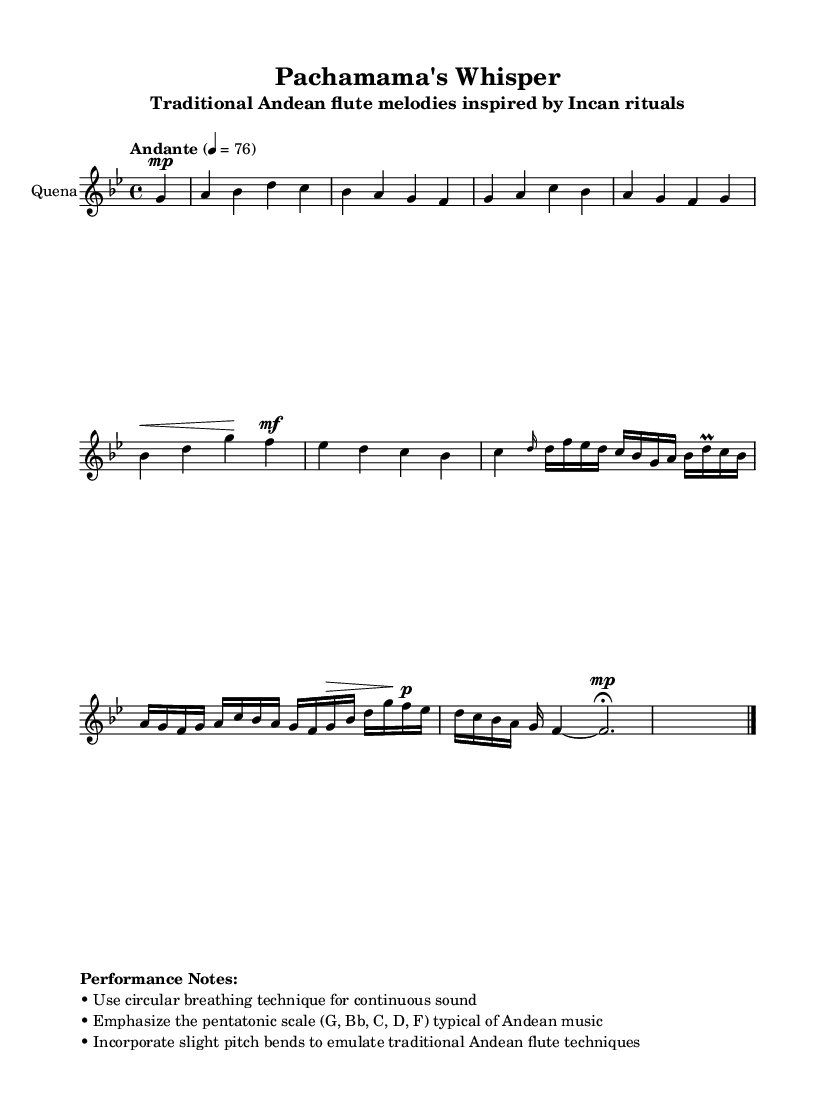What is the key signature of this music? The key signature indicates that the piece is in G minor, which includes two flats: B flat and E flat.
Answer: G minor What is the time signature of the piece? The time signature is found at the beginning of the score and is written as 4/4, which means there are four beats in a measure and a quarter note gets one beat.
Answer: 4/4 What is the tempo marking for this piece? The tempo is indicated at the beginning with the word "Andante" and a metronome mark of 76. This suggests a moderately slow and walking pace.
Answer: Andante, 76 What is the dynamic marking at the beginning of the piece? The first dynamic marking indicates "mp," which stands for mezzo-piano, meaning moderately soft. This applies to the first note of the piece.
Answer: mezzo-piano What scale is emphasized in the performance notes? The performance notes highlight the pentatonic scale typical of Andean music, specifically noting the pitches: G, B flat, C, D, and F.
Answer: Pentatonic scale What breathing technique is suggested in the performance notes? The performance notes advise the use of the circular breathing technique, which allows the musician to produce a continuous sound without pauses.
Answer: Circular breathing What is the significance of the ritual inspiration mentioned in the subtitle? The subtitle "Traditional Andean flute melodies inspired by Incan rituals" suggests that the melodies are representative of the cultural and spiritual practices of the Incan civilization, linking music to their rituals and traditions.
Answer: Incan rituals 